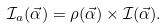<formula> <loc_0><loc_0><loc_500><loc_500>\mathcal { I } _ { a } ( \vec { \alpha } ) = \rho ( \vec { \alpha } ) \times \mathcal { I } ( \vec { \alpha } ) .</formula> 